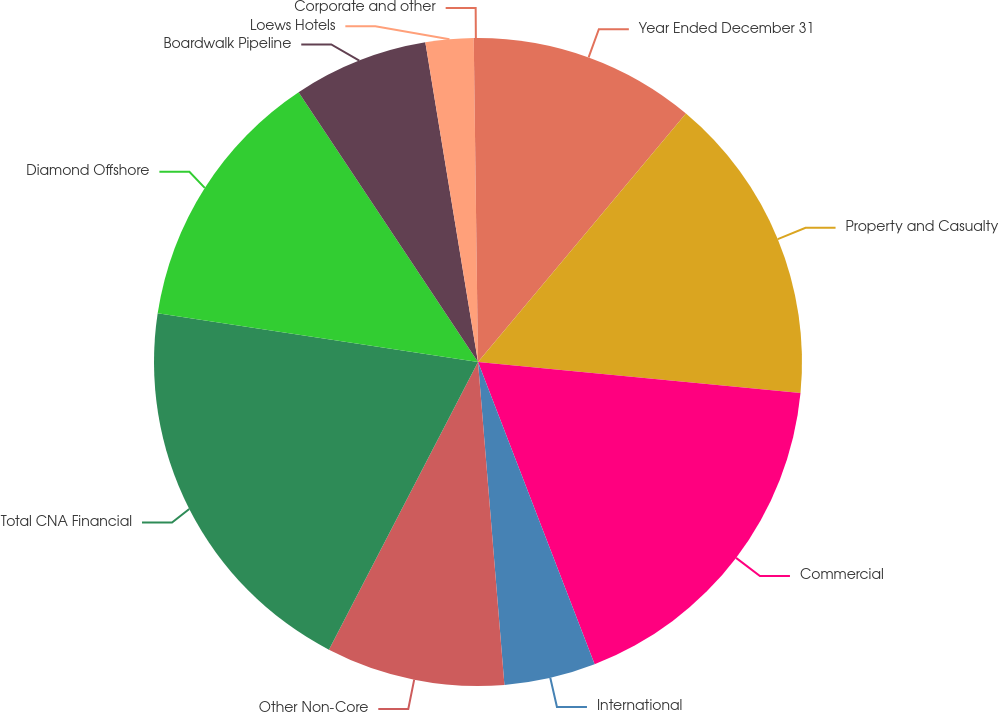<chart> <loc_0><loc_0><loc_500><loc_500><pie_chart><fcel>Year Ended December 31<fcel>Property and Casualty<fcel>Commercial<fcel>International<fcel>Other Non-Core<fcel>Total CNA Financial<fcel>Diamond Offshore<fcel>Boardwalk Pipeline<fcel>Loews Hotels<fcel>Corporate and other<nl><fcel>11.09%<fcel>15.44%<fcel>17.61%<fcel>4.56%<fcel>8.91%<fcel>19.79%<fcel>13.26%<fcel>6.74%<fcel>2.39%<fcel>0.21%<nl></chart> 